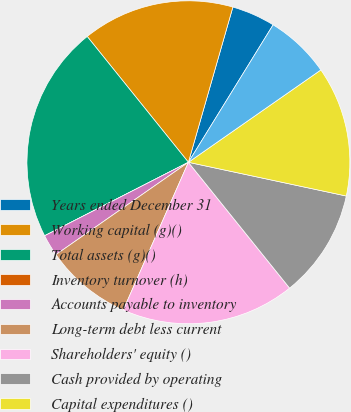<chart> <loc_0><loc_0><loc_500><loc_500><pie_chart><fcel>Years ended December 31<fcel>Working capital (g)()<fcel>Total assets (g)()<fcel>Inventory turnover (h)<fcel>Accounts payable to inventory<fcel>Long-term debt less current<fcel>Shareholders' equity ()<fcel>Cash provided by operating<fcel>Capital expenditures ()<fcel>Free cash flow (j)()<nl><fcel>4.35%<fcel>15.22%<fcel>21.74%<fcel>0.0%<fcel>2.17%<fcel>8.7%<fcel>17.39%<fcel>10.87%<fcel>13.04%<fcel>6.52%<nl></chart> 